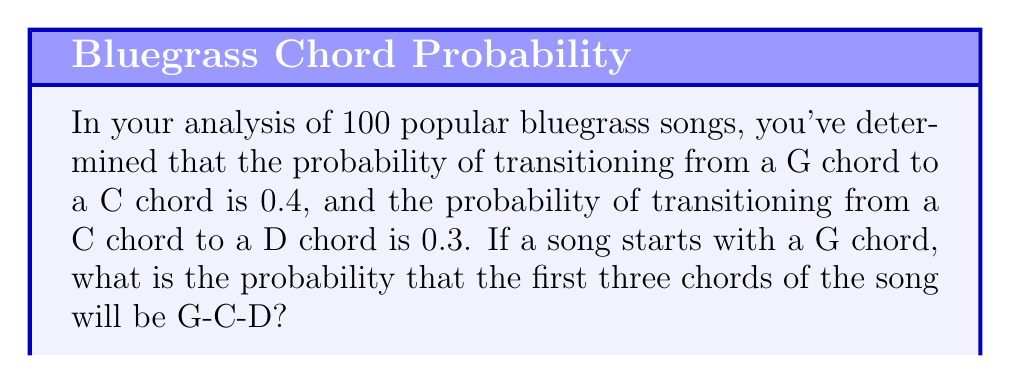Provide a solution to this math problem. Let's approach this step-by-step using Markov chains:

1) First, we need to understand what the question is asking. We're looking for the probability of the sequence G-C-D occurring, given that we start with G.

2) In Markov chain terminology, we're calculating:

   $P(G \rightarrow C \rightarrow D) = P(G \rightarrow C) \cdot P(C \rightarrow D)$

3) We're given two probabilities:
   - $P(G \rightarrow C) = 0.4$
   - $P(C \rightarrow D) = 0.3$

4) Now, we can simply multiply these probabilities:

   $P(G \rightarrow C \rightarrow D) = 0.4 \cdot 0.3$

5) Calculating:

   $P(G \rightarrow C \rightarrow D) = 0.4 \cdot 0.3 = 0.12$

6) Therefore, the probability of the chord progression G-C-D occurring, given that we start with G, is 0.12 or 12%.

This Markov chain approach assumes that the probability of transitioning to a chord depends only on the current chord, not on the history of previous chords.
Answer: 0.12 